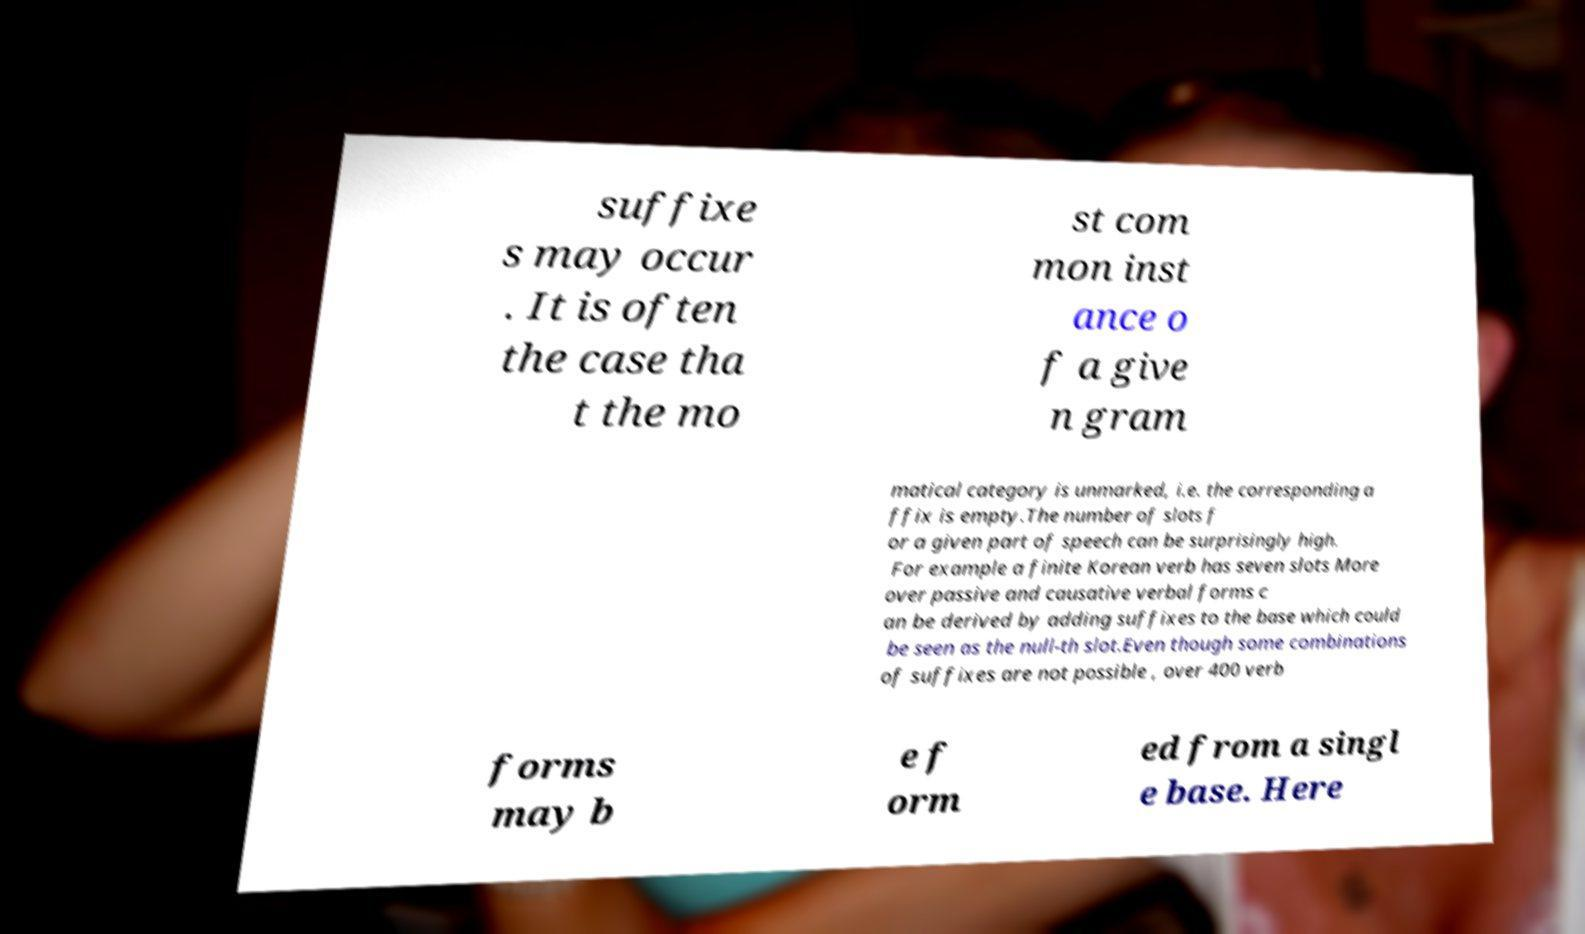I need the written content from this picture converted into text. Can you do that? suffixe s may occur . It is often the case tha t the mo st com mon inst ance o f a give n gram matical category is unmarked, i.e. the corresponding a ffix is empty.The number of slots f or a given part of speech can be surprisingly high. For example a finite Korean verb has seven slots More over passive and causative verbal forms c an be derived by adding suffixes to the base which could be seen as the null-th slot.Even though some combinations of suffixes are not possible , over 400 verb forms may b e f orm ed from a singl e base. Here 